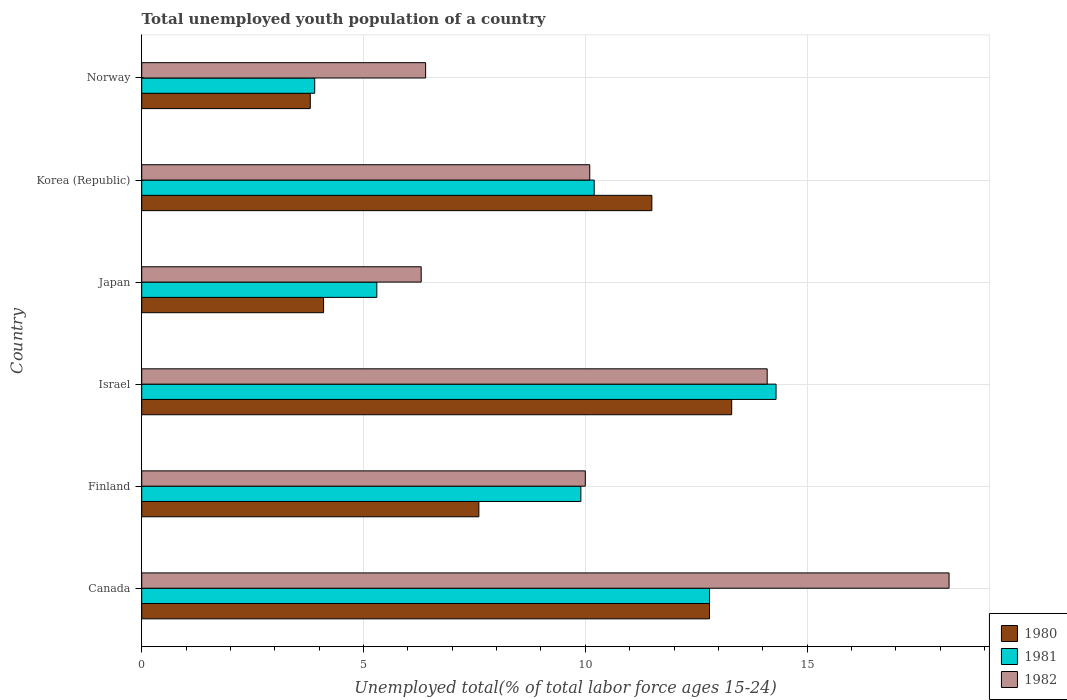What is the label of the 1st group of bars from the top?
Your response must be concise. Norway. What is the percentage of total unemployed youth population of a country in 1981 in Canada?
Offer a very short reply. 12.8. Across all countries, what is the maximum percentage of total unemployed youth population of a country in 1982?
Offer a terse response. 18.2. Across all countries, what is the minimum percentage of total unemployed youth population of a country in 1980?
Your response must be concise. 3.8. In which country was the percentage of total unemployed youth population of a country in 1981 minimum?
Make the answer very short. Norway. What is the total percentage of total unemployed youth population of a country in 1981 in the graph?
Provide a succinct answer. 56.4. What is the difference between the percentage of total unemployed youth population of a country in 1980 in Canada and that in Korea (Republic)?
Your response must be concise. 1.3. What is the difference between the percentage of total unemployed youth population of a country in 1981 in Israel and the percentage of total unemployed youth population of a country in 1982 in Canada?
Give a very brief answer. -3.9. What is the average percentage of total unemployed youth population of a country in 1980 per country?
Ensure brevity in your answer.  8.85. What is the difference between the percentage of total unemployed youth population of a country in 1980 and percentage of total unemployed youth population of a country in 1982 in Korea (Republic)?
Provide a short and direct response. 1.4. In how many countries, is the percentage of total unemployed youth population of a country in 1981 greater than 3 %?
Your response must be concise. 6. What is the ratio of the percentage of total unemployed youth population of a country in 1980 in Finland to that in Korea (Republic)?
Give a very brief answer. 0.66. Is the percentage of total unemployed youth population of a country in 1980 in Japan less than that in Norway?
Your response must be concise. No. Is the difference between the percentage of total unemployed youth population of a country in 1980 in Israel and Norway greater than the difference between the percentage of total unemployed youth population of a country in 1982 in Israel and Norway?
Provide a short and direct response. Yes. What is the difference between the highest and the lowest percentage of total unemployed youth population of a country in 1980?
Your response must be concise. 9.5. In how many countries, is the percentage of total unemployed youth population of a country in 1982 greater than the average percentage of total unemployed youth population of a country in 1982 taken over all countries?
Make the answer very short. 2. What does the 1st bar from the bottom in Korea (Republic) represents?
Offer a very short reply. 1980. Is it the case that in every country, the sum of the percentage of total unemployed youth population of a country in 1981 and percentage of total unemployed youth population of a country in 1982 is greater than the percentage of total unemployed youth population of a country in 1980?
Make the answer very short. Yes. Are all the bars in the graph horizontal?
Provide a succinct answer. Yes. How many countries are there in the graph?
Ensure brevity in your answer.  6. Does the graph contain any zero values?
Your answer should be compact. No. What is the title of the graph?
Offer a very short reply. Total unemployed youth population of a country. Does "2002" appear as one of the legend labels in the graph?
Make the answer very short. No. What is the label or title of the X-axis?
Your answer should be compact. Unemployed total(% of total labor force ages 15-24). What is the label or title of the Y-axis?
Offer a very short reply. Country. What is the Unemployed total(% of total labor force ages 15-24) of 1980 in Canada?
Your response must be concise. 12.8. What is the Unemployed total(% of total labor force ages 15-24) of 1981 in Canada?
Keep it short and to the point. 12.8. What is the Unemployed total(% of total labor force ages 15-24) of 1982 in Canada?
Your answer should be very brief. 18.2. What is the Unemployed total(% of total labor force ages 15-24) of 1980 in Finland?
Keep it short and to the point. 7.6. What is the Unemployed total(% of total labor force ages 15-24) of 1981 in Finland?
Your response must be concise. 9.9. What is the Unemployed total(% of total labor force ages 15-24) of 1982 in Finland?
Offer a very short reply. 10. What is the Unemployed total(% of total labor force ages 15-24) of 1980 in Israel?
Provide a succinct answer. 13.3. What is the Unemployed total(% of total labor force ages 15-24) in 1981 in Israel?
Your response must be concise. 14.3. What is the Unemployed total(% of total labor force ages 15-24) in 1982 in Israel?
Keep it short and to the point. 14.1. What is the Unemployed total(% of total labor force ages 15-24) in 1980 in Japan?
Offer a very short reply. 4.1. What is the Unemployed total(% of total labor force ages 15-24) of 1981 in Japan?
Offer a terse response. 5.3. What is the Unemployed total(% of total labor force ages 15-24) in 1982 in Japan?
Offer a terse response. 6.3. What is the Unemployed total(% of total labor force ages 15-24) in 1981 in Korea (Republic)?
Your answer should be very brief. 10.2. What is the Unemployed total(% of total labor force ages 15-24) in 1982 in Korea (Republic)?
Your answer should be compact. 10.1. What is the Unemployed total(% of total labor force ages 15-24) in 1980 in Norway?
Give a very brief answer. 3.8. What is the Unemployed total(% of total labor force ages 15-24) of 1981 in Norway?
Provide a succinct answer. 3.9. What is the Unemployed total(% of total labor force ages 15-24) in 1982 in Norway?
Your response must be concise. 6.4. Across all countries, what is the maximum Unemployed total(% of total labor force ages 15-24) of 1980?
Your answer should be very brief. 13.3. Across all countries, what is the maximum Unemployed total(% of total labor force ages 15-24) in 1981?
Offer a terse response. 14.3. Across all countries, what is the maximum Unemployed total(% of total labor force ages 15-24) in 1982?
Your response must be concise. 18.2. Across all countries, what is the minimum Unemployed total(% of total labor force ages 15-24) of 1980?
Ensure brevity in your answer.  3.8. Across all countries, what is the minimum Unemployed total(% of total labor force ages 15-24) of 1981?
Give a very brief answer. 3.9. Across all countries, what is the minimum Unemployed total(% of total labor force ages 15-24) of 1982?
Ensure brevity in your answer.  6.3. What is the total Unemployed total(% of total labor force ages 15-24) of 1980 in the graph?
Offer a terse response. 53.1. What is the total Unemployed total(% of total labor force ages 15-24) of 1981 in the graph?
Ensure brevity in your answer.  56.4. What is the total Unemployed total(% of total labor force ages 15-24) in 1982 in the graph?
Offer a very short reply. 65.1. What is the difference between the Unemployed total(% of total labor force ages 15-24) in 1982 in Canada and that in Finland?
Offer a terse response. 8.2. What is the difference between the Unemployed total(% of total labor force ages 15-24) of 1981 in Canada and that in Korea (Republic)?
Give a very brief answer. 2.6. What is the difference between the Unemployed total(% of total labor force ages 15-24) of 1982 in Canada and that in Korea (Republic)?
Your answer should be compact. 8.1. What is the difference between the Unemployed total(% of total labor force ages 15-24) in 1980 in Canada and that in Norway?
Ensure brevity in your answer.  9. What is the difference between the Unemployed total(% of total labor force ages 15-24) in 1981 in Finland and that in Israel?
Your answer should be very brief. -4.4. What is the difference between the Unemployed total(% of total labor force ages 15-24) of 1982 in Finland and that in Israel?
Your answer should be compact. -4.1. What is the difference between the Unemployed total(% of total labor force ages 15-24) in 1980 in Finland and that in Japan?
Make the answer very short. 3.5. What is the difference between the Unemployed total(% of total labor force ages 15-24) in 1982 in Finland and that in Japan?
Your answer should be compact. 3.7. What is the difference between the Unemployed total(% of total labor force ages 15-24) in 1980 in Finland and that in Korea (Republic)?
Your answer should be compact. -3.9. What is the difference between the Unemployed total(% of total labor force ages 15-24) in 1982 in Finland and that in Korea (Republic)?
Give a very brief answer. -0.1. What is the difference between the Unemployed total(% of total labor force ages 15-24) of 1980 in Israel and that in Japan?
Your response must be concise. 9.2. What is the difference between the Unemployed total(% of total labor force ages 15-24) in 1981 in Israel and that in Korea (Republic)?
Your answer should be very brief. 4.1. What is the difference between the Unemployed total(% of total labor force ages 15-24) in 1980 in Israel and that in Norway?
Make the answer very short. 9.5. What is the difference between the Unemployed total(% of total labor force ages 15-24) in 1982 in Israel and that in Norway?
Offer a very short reply. 7.7. What is the difference between the Unemployed total(% of total labor force ages 15-24) of 1982 in Japan and that in Korea (Republic)?
Make the answer very short. -3.8. What is the difference between the Unemployed total(% of total labor force ages 15-24) in 1980 in Korea (Republic) and that in Norway?
Your response must be concise. 7.7. What is the difference between the Unemployed total(% of total labor force ages 15-24) of 1980 in Canada and the Unemployed total(% of total labor force ages 15-24) of 1982 in Finland?
Provide a short and direct response. 2.8. What is the difference between the Unemployed total(% of total labor force ages 15-24) of 1981 in Canada and the Unemployed total(% of total labor force ages 15-24) of 1982 in Finland?
Make the answer very short. 2.8. What is the difference between the Unemployed total(% of total labor force ages 15-24) of 1980 in Canada and the Unemployed total(% of total labor force ages 15-24) of 1981 in Israel?
Make the answer very short. -1.5. What is the difference between the Unemployed total(% of total labor force ages 15-24) of 1981 in Canada and the Unemployed total(% of total labor force ages 15-24) of 1982 in Israel?
Offer a very short reply. -1.3. What is the difference between the Unemployed total(% of total labor force ages 15-24) of 1980 in Canada and the Unemployed total(% of total labor force ages 15-24) of 1981 in Japan?
Your answer should be very brief. 7.5. What is the difference between the Unemployed total(% of total labor force ages 15-24) of 1981 in Canada and the Unemployed total(% of total labor force ages 15-24) of 1982 in Japan?
Provide a succinct answer. 6.5. What is the difference between the Unemployed total(% of total labor force ages 15-24) in 1980 in Canada and the Unemployed total(% of total labor force ages 15-24) in 1981 in Korea (Republic)?
Give a very brief answer. 2.6. What is the difference between the Unemployed total(% of total labor force ages 15-24) of 1980 in Canada and the Unemployed total(% of total labor force ages 15-24) of 1981 in Norway?
Your answer should be compact. 8.9. What is the difference between the Unemployed total(% of total labor force ages 15-24) of 1980 in Finland and the Unemployed total(% of total labor force ages 15-24) of 1982 in Israel?
Your response must be concise. -6.5. What is the difference between the Unemployed total(% of total labor force ages 15-24) of 1980 in Finland and the Unemployed total(% of total labor force ages 15-24) of 1981 in Japan?
Make the answer very short. 2.3. What is the difference between the Unemployed total(% of total labor force ages 15-24) of 1981 in Finland and the Unemployed total(% of total labor force ages 15-24) of 1982 in Japan?
Offer a terse response. 3.6. What is the difference between the Unemployed total(% of total labor force ages 15-24) in 1980 in Finland and the Unemployed total(% of total labor force ages 15-24) in 1982 in Korea (Republic)?
Your response must be concise. -2.5. What is the difference between the Unemployed total(% of total labor force ages 15-24) of 1981 in Finland and the Unemployed total(% of total labor force ages 15-24) of 1982 in Korea (Republic)?
Offer a very short reply. -0.2. What is the difference between the Unemployed total(% of total labor force ages 15-24) of 1981 in Finland and the Unemployed total(% of total labor force ages 15-24) of 1982 in Norway?
Give a very brief answer. 3.5. What is the difference between the Unemployed total(% of total labor force ages 15-24) in 1980 in Israel and the Unemployed total(% of total labor force ages 15-24) in 1982 in Japan?
Give a very brief answer. 7. What is the difference between the Unemployed total(% of total labor force ages 15-24) of 1981 in Israel and the Unemployed total(% of total labor force ages 15-24) of 1982 in Japan?
Offer a terse response. 8. What is the difference between the Unemployed total(% of total labor force ages 15-24) of 1980 in Israel and the Unemployed total(% of total labor force ages 15-24) of 1981 in Korea (Republic)?
Offer a very short reply. 3.1. What is the difference between the Unemployed total(% of total labor force ages 15-24) of 1981 in Israel and the Unemployed total(% of total labor force ages 15-24) of 1982 in Korea (Republic)?
Provide a succinct answer. 4.2. What is the difference between the Unemployed total(% of total labor force ages 15-24) of 1980 in Israel and the Unemployed total(% of total labor force ages 15-24) of 1982 in Norway?
Ensure brevity in your answer.  6.9. What is the difference between the Unemployed total(% of total labor force ages 15-24) of 1981 in Israel and the Unemployed total(% of total labor force ages 15-24) of 1982 in Norway?
Keep it short and to the point. 7.9. What is the difference between the Unemployed total(% of total labor force ages 15-24) in 1980 in Japan and the Unemployed total(% of total labor force ages 15-24) in 1982 in Norway?
Make the answer very short. -2.3. What is the difference between the Unemployed total(% of total labor force ages 15-24) in 1981 in Japan and the Unemployed total(% of total labor force ages 15-24) in 1982 in Norway?
Provide a succinct answer. -1.1. What is the difference between the Unemployed total(% of total labor force ages 15-24) of 1980 in Korea (Republic) and the Unemployed total(% of total labor force ages 15-24) of 1981 in Norway?
Your response must be concise. 7.6. What is the difference between the Unemployed total(% of total labor force ages 15-24) of 1980 in Korea (Republic) and the Unemployed total(% of total labor force ages 15-24) of 1982 in Norway?
Your answer should be compact. 5.1. What is the difference between the Unemployed total(% of total labor force ages 15-24) in 1981 in Korea (Republic) and the Unemployed total(% of total labor force ages 15-24) in 1982 in Norway?
Ensure brevity in your answer.  3.8. What is the average Unemployed total(% of total labor force ages 15-24) in 1980 per country?
Make the answer very short. 8.85. What is the average Unemployed total(% of total labor force ages 15-24) of 1981 per country?
Your answer should be very brief. 9.4. What is the average Unemployed total(% of total labor force ages 15-24) of 1982 per country?
Your answer should be compact. 10.85. What is the difference between the Unemployed total(% of total labor force ages 15-24) in 1980 and Unemployed total(% of total labor force ages 15-24) in 1981 in Canada?
Offer a terse response. 0. What is the difference between the Unemployed total(% of total labor force ages 15-24) in 1980 and Unemployed total(% of total labor force ages 15-24) in 1981 in Finland?
Provide a succinct answer. -2.3. What is the difference between the Unemployed total(% of total labor force ages 15-24) in 1980 and Unemployed total(% of total labor force ages 15-24) in 1982 in Finland?
Your answer should be very brief. -2.4. What is the difference between the Unemployed total(% of total labor force ages 15-24) in 1980 and Unemployed total(% of total labor force ages 15-24) in 1982 in Israel?
Offer a very short reply. -0.8. What is the difference between the Unemployed total(% of total labor force ages 15-24) in 1981 and Unemployed total(% of total labor force ages 15-24) in 1982 in Israel?
Make the answer very short. 0.2. What is the difference between the Unemployed total(% of total labor force ages 15-24) in 1980 and Unemployed total(% of total labor force ages 15-24) in 1981 in Japan?
Ensure brevity in your answer.  -1.2. What is the difference between the Unemployed total(% of total labor force ages 15-24) in 1980 and Unemployed total(% of total labor force ages 15-24) in 1982 in Japan?
Keep it short and to the point. -2.2. What is the difference between the Unemployed total(% of total labor force ages 15-24) in 1981 and Unemployed total(% of total labor force ages 15-24) in 1982 in Japan?
Provide a succinct answer. -1. What is the difference between the Unemployed total(% of total labor force ages 15-24) in 1980 and Unemployed total(% of total labor force ages 15-24) in 1981 in Norway?
Your answer should be very brief. -0.1. What is the difference between the Unemployed total(% of total labor force ages 15-24) of 1981 and Unemployed total(% of total labor force ages 15-24) of 1982 in Norway?
Your answer should be compact. -2.5. What is the ratio of the Unemployed total(% of total labor force ages 15-24) of 1980 in Canada to that in Finland?
Your response must be concise. 1.68. What is the ratio of the Unemployed total(% of total labor force ages 15-24) of 1981 in Canada to that in Finland?
Your answer should be very brief. 1.29. What is the ratio of the Unemployed total(% of total labor force ages 15-24) of 1982 in Canada to that in Finland?
Your response must be concise. 1.82. What is the ratio of the Unemployed total(% of total labor force ages 15-24) in 1980 in Canada to that in Israel?
Your response must be concise. 0.96. What is the ratio of the Unemployed total(% of total labor force ages 15-24) in 1981 in Canada to that in Israel?
Offer a very short reply. 0.9. What is the ratio of the Unemployed total(% of total labor force ages 15-24) of 1982 in Canada to that in Israel?
Keep it short and to the point. 1.29. What is the ratio of the Unemployed total(% of total labor force ages 15-24) of 1980 in Canada to that in Japan?
Your answer should be compact. 3.12. What is the ratio of the Unemployed total(% of total labor force ages 15-24) in 1981 in Canada to that in Japan?
Your answer should be very brief. 2.42. What is the ratio of the Unemployed total(% of total labor force ages 15-24) in 1982 in Canada to that in Japan?
Offer a terse response. 2.89. What is the ratio of the Unemployed total(% of total labor force ages 15-24) in 1980 in Canada to that in Korea (Republic)?
Your answer should be compact. 1.11. What is the ratio of the Unemployed total(% of total labor force ages 15-24) of 1981 in Canada to that in Korea (Republic)?
Keep it short and to the point. 1.25. What is the ratio of the Unemployed total(% of total labor force ages 15-24) in 1982 in Canada to that in Korea (Republic)?
Offer a very short reply. 1.8. What is the ratio of the Unemployed total(% of total labor force ages 15-24) in 1980 in Canada to that in Norway?
Your answer should be compact. 3.37. What is the ratio of the Unemployed total(% of total labor force ages 15-24) of 1981 in Canada to that in Norway?
Offer a terse response. 3.28. What is the ratio of the Unemployed total(% of total labor force ages 15-24) in 1982 in Canada to that in Norway?
Make the answer very short. 2.84. What is the ratio of the Unemployed total(% of total labor force ages 15-24) of 1981 in Finland to that in Israel?
Your response must be concise. 0.69. What is the ratio of the Unemployed total(% of total labor force ages 15-24) in 1982 in Finland to that in Israel?
Ensure brevity in your answer.  0.71. What is the ratio of the Unemployed total(% of total labor force ages 15-24) in 1980 in Finland to that in Japan?
Ensure brevity in your answer.  1.85. What is the ratio of the Unemployed total(% of total labor force ages 15-24) of 1981 in Finland to that in Japan?
Give a very brief answer. 1.87. What is the ratio of the Unemployed total(% of total labor force ages 15-24) of 1982 in Finland to that in Japan?
Offer a terse response. 1.59. What is the ratio of the Unemployed total(% of total labor force ages 15-24) in 1980 in Finland to that in Korea (Republic)?
Provide a short and direct response. 0.66. What is the ratio of the Unemployed total(% of total labor force ages 15-24) of 1981 in Finland to that in Korea (Republic)?
Make the answer very short. 0.97. What is the ratio of the Unemployed total(% of total labor force ages 15-24) of 1982 in Finland to that in Korea (Republic)?
Make the answer very short. 0.99. What is the ratio of the Unemployed total(% of total labor force ages 15-24) of 1981 in Finland to that in Norway?
Provide a succinct answer. 2.54. What is the ratio of the Unemployed total(% of total labor force ages 15-24) in 1982 in Finland to that in Norway?
Offer a terse response. 1.56. What is the ratio of the Unemployed total(% of total labor force ages 15-24) of 1980 in Israel to that in Japan?
Give a very brief answer. 3.24. What is the ratio of the Unemployed total(% of total labor force ages 15-24) of 1981 in Israel to that in Japan?
Offer a terse response. 2.7. What is the ratio of the Unemployed total(% of total labor force ages 15-24) in 1982 in Israel to that in Japan?
Make the answer very short. 2.24. What is the ratio of the Unemployed total(% of total labor force ages 15-24) of 1980 in Israel to that in Korea (Republic)?
Your answer should be very brief. 1.16. What is the ratio of the Unemployed total(% of total labor force ages 15-24) of 1981 in Israel to that in Korea (Republic)?
Ensure brevity in your answer.  1.4. What is the ratio of the Unemployed total(% of total labor force ages 15-24) in 1982 in Israel to that in Korea (Republic)?
Your answer should be compact. 1.4. What is the ratio of the Unemployed total(% of total labor force ages 15-24) of 1980 in Israel to that in Norway?
Your answer should be compact. 3.5. What is the ratio of the Unemployed total(% of total labor force ages 15-24) of 1981 in Israel to that in Norway?
Provide a short and direct response. 3.67. What is the ratio of the Unemployed total(% of total labor force ages 15-24) in 1982 in Israel to that in Norway?
Offer a terse response. 2.2. What is the ratio of the Unemployed total(% of total labor force ages 15-24) in 1980 in Japan to that in Korea (Republic)?
Make the answer very short. 0.36. What is the ratio of the Unemployed total(% of total labor force ages 15-24) in 1981 in Japan to that in Korea (Republic)?
Provide a succinct answer. 0.52. What is the ratio of the Unemployed total(% of total labor force ages 15-24) of 1982 in Japan to that in Korea (Republic)?
Ensure brevity in your answer.  0.62. What is the ratio of the Unemployed total(% of total labor force ages 15-24) in 1980 in Japan to that in Norway?
Ensure brevity in your answer.  1.08. What is the ratio of the Unemployed total(% of total labor force ages 15-24) in 1981 in Japan to that in Norway?
Your answer should be compact. 1.36. What is the ratio of the Unemployed total(% of total labor force ages 15-24) in 1982 in Japan to that in Norway?
Offer a terse response. 0.98. What is the ratio of the Unemployed total(% of total labor force ages 15-24) in 1980 in Korea (Republic) to that in Norway?
Your answer should be very brief. 3.03. What is the ratio of the Unemployed total(% of total labor force ages 15-24) in 1981 in Korea (Republic) to that in Norway?
Provide a short and direct response. 2.62. What is the ratio of the Unemployed total(% of total labor force ages 15-24) in 1982 in Korea (Republic) to that in Norway?
Your response must be concise. 1.58. What is the difference between the highest and the second highest Unemployed total(% of total labor force ages 15-24) of 1980?
Give a very brief answer. 0.5. What is the difference between the highest and the lowest Unemployed total(% of total labor force ages 15-24) of 1981?
Provide a succinct answer. 10.4. What is the difference between the highest and the lowest Unemployed total(% of total labor force ages 15-24) in 1982?
Offer a terse response. 11.9. 